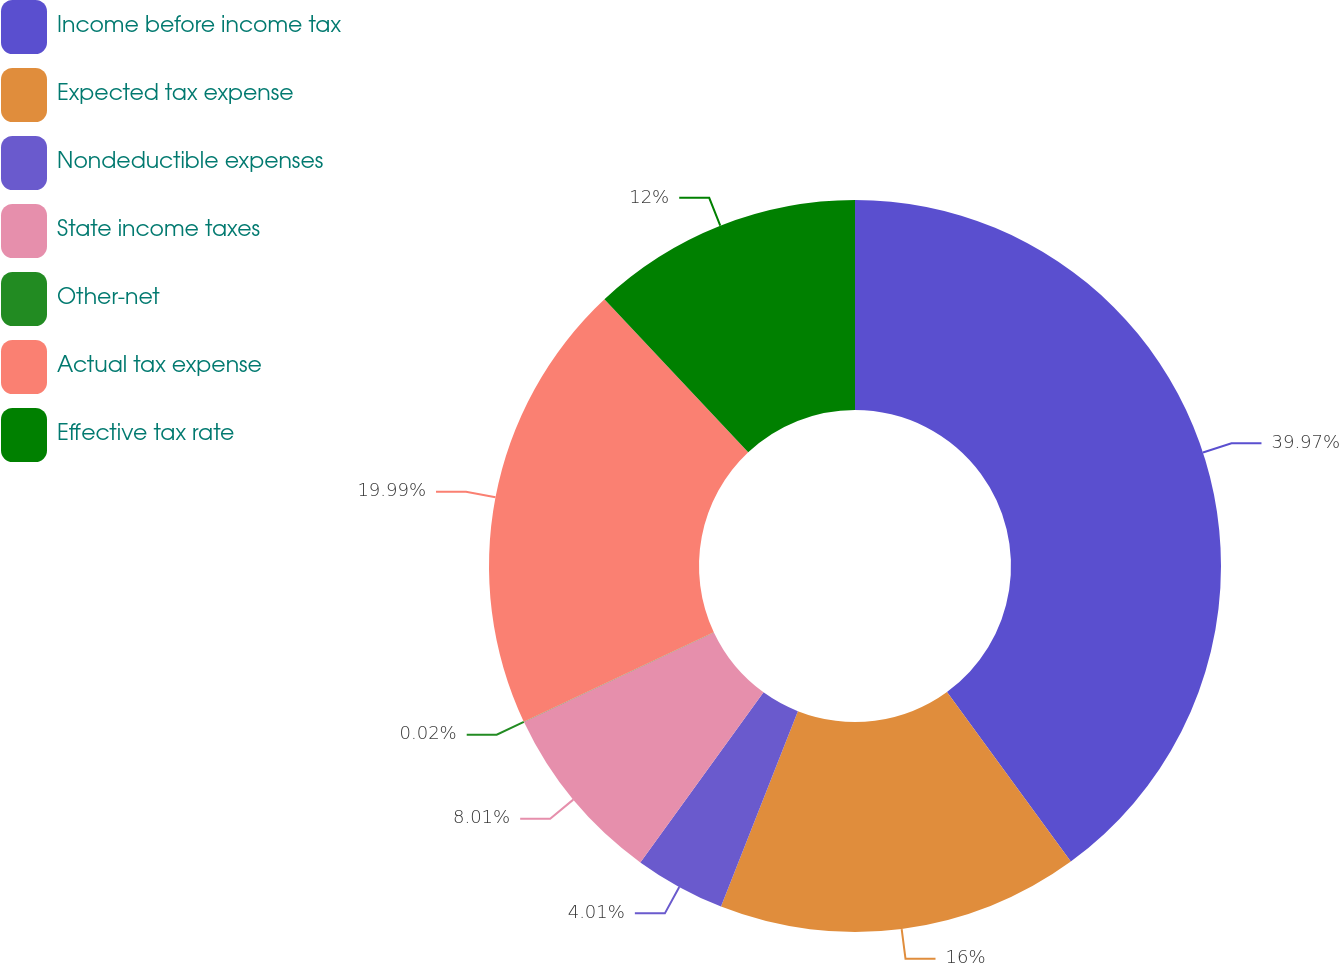Convert chart to OTSL. <chart><loc_0><loc_0><loc_500><loc_500><pie_chart><fcel>Income before income tax<fcel>Expected tax expense<fcel>Nondeductible expenses<fcel>State income taxes<fcel>Other-net<fcel>Actual tax expense<fcel>Effective tax rate<nl><fcel>39.96%<fcel>16.0%<fcel>4.01%<fcel>8.01%<fcel>0.02%<fcel>19.99%<fcel>12.0%<nl></chart> 